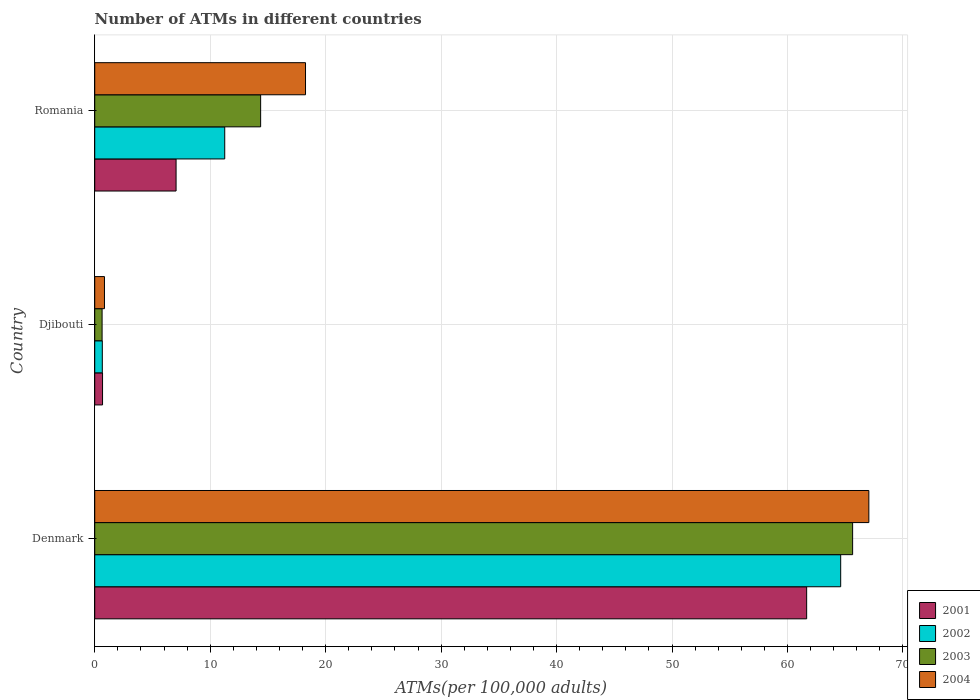How many groups of bars are there?
Your answer should be compact. 3. Are the number of bars per tick equal to the number of legend labels?
Your answer should be very brief. Yes. How many bars are there on the 3rd tick from the top?
Offer a very short reply. 4. How many bars are there on the 2nd tick from the bottom?
Your response must be concise. 4. What is the label of the 2nd group of bars from the top?
Offer a terse response. Djibouti. What is the number of ATMs in 2002 in Denmark?
Your answer should be compact. 64.61. Across all countries, what is the maximum number of ATMs in 2004?
Make the answer very short. 67.04. Across all countries, what is the minimum number of ATMs in 2003?
Keep it short and to the point. 0.64. In which country was the number of ATMs in 2004 maximum?
Offer a very short reply. Denmark. In which country was the number of ATMs in 2003 minimum?
Your answer should be very brief. Djibouti. What is the total number of ATMs in 2001 in the graph?
Give a very brief answer. 69.38. What is the difference between the number of ATMs in 2004 in Denmark and that in Djibouti?
Make the answer very short. 66.2. What is the difference between the number of ATMs in 2003 in Denmark and the number of ATMs in 2002 in Djibouti?
Your response must be concise. 64.98. What is the average number of ATMs in 2001 per country?
Your answer should be very brief. 23.13. What is the difference between the number of ATMs in 2001 and number of ATMs in 2003 in Denmark?
Offer a very short reply. -3.98. What is the ratio of the number of ATMs in 2002 in Denmark to that in Djibouti?
Offer a very short reply. 98.45. Is the difference between the number of ATMs in 2001 in Denmark and Romania greater than the difference between the number of ATMs in 2003 in Denmark and Romania?
Offer a very short reply. Yes. What is the difference between the highest and the second highest number of ATMs in 2003?
Offer a terse response. 51.27. What is the difference between the highest and the lowest number of ATMs in 2003?
Offer a terse response. 65. In how many countries, is the number of ATMs in 2004 greater than the average number of ATMs in 2004 taken over all countries?
Your response must be concise. 1. Is it the case that in every country, the sum of the number of ATMs in 2001 and number of ATMs in 2003 is greater than the sum of number of ATMs in 2004 and number of ATMs in 2002?
Ensure brevity in your answer.  No. What does the 1st bar from the top in Djibouti represents?
Provide a succinct answer. 2004. Is it the case that in every country, the sum of the number of ATMs in 2004 and number of ATMs in 2002 is greater than the number of ATMs in 2001?
Your response must be concise. Yes. Are all the bars in the graph horizontal?
Make the answer very short. Yes. How many countries are there in the graph?
Provide a succinct answer. 3. Are the values on the major ticks of X-axis written in scientific E-notation?
Your response must be concise. No. Does the graph contain any zero values?
Your answer should be very brief. No. Does the graph contain grids?
Make the answer very short. Yes. Where does the legend appear in the graph?
Offer a terse response. Bottom right. How many legend labels are there?
Your response must be concise. 4. How are the legend labels stacked?
Provide a short and direct response. Vertical. What is the title of the graph?
Offer a very short reply. Number of ATMs in different countries. What is the label or title of the X-axis?
Give a very brief answer. ATMs(per 100,0 adults). What is the label or title of the Y-axis?
Make the answer very short. Country. What is the ATMs(per 100,000 adults) in 2001 in Denmark?
Provide a succinct answer. 61.66. What is the ATMs(per 100,000 adults) in 2002 in Denmark?
Your answer should be very brief. 64.61. What is the ATMs(per 100,000 adults) in 2003 in Denmark?
Ensure brevity in your answer.  65.64. What is the ATMs(per 100,000 adults) of 2004 in Denmark?
Your response must be concise. 67.04. What is the ATMs(per 100,000 adults) in 2001 in Djibouti?
Your answer should be compact. 0.68. What is the ATMs(per 100,000 adults) of 2002 in Djibouti?
Your answer should be very brief. 0.66. What is the ATMs(per 100,000 adults) of 2003 in Djibouti?
Your answer should be very brief. 0.64. What is the ATMs(per 100,000 adults) in 2004 in Djibouti?
Provide a succinct answer. 0.84. What is the ATMs(per 100,000 adults) in 2001 in Romania?
Keep it short and to the point. 7.04. What is the ATMs(per 100,000 adults) in 2002 in Romania?
Your answer should be compact. 11.26. What is the ATMs(per 100,000 adults) in 2003 in Romania?
Offer a terse response. 14.37. What is the ATMs(per 100,000 adults) in 2004 in Romania?
Provide a succinct answer. 18.26. Across all countries, what is the maximum ATMs(per 100,000 adults) in 2001?
Ensure brevity in your answer.  61.66. Across all countries, what is the maximum ATMs(per 100,000 adults) of 2002?
Give a very brief answer. 64.61. Across all countries, what is the maximum ATMs(per 100,000 adults) in 2003?
Offer a terse response. 65.64. Across all countries, what is the maximum ATMs(per 100,000 adults) in 2004?
Give a very brief answer. 67.04. Across all countries, what is the minimum ATMs(per 100,000 adults) in 2001?
Offer a terse response. 0.68. Across all countries, what is the minimum ATMs(per 100,000 adults) of 2002?
Provide a short and direct response. 0.66. Across all countries, what is the minimum ATMs(per 100,000 adults) in 2003?
Your answer should be compact. 0.64. Across all countries, what is the minimum ATMs(per 100,000 adults) of 2004?
Offer a very short reply. 0.84. What is the total ATMs(per 100,000 adults) in 2001 in the graph?
Provide a short and direct response. 69.38. What is the total ATMs(per 100,000 adults) of 2002 in the graph?
Ensure brevity in your answer.  76.52. What is the total ATMs(per 100,000 adults) of 2003 in the graph?
Your answer should be compact. 80.65. What is the total ATMs(per 100,000 adults) of 2004 in the graph?
Keep it short and to the point. 86.14. What is the difference between the ATMs(per 100,000 adults) of 2001 in Denmark and that in Djibouti?
Provide a succinct answer. 60.98. What is the difference between the ATMs(per 100,000 adults) in 2002 in Denmark and that in Djibouti?
Offer a very short reply. 63.95. What is the difference between the ATMs(per 100,000 adults) in 2003 in Denmark and that in Djibouti?
Make the answer very short. 65. What is the difference between the ATMs(per 100,000 adults) in 2004 in Denmark and that in Djibouti?
Your answer should be very brief. 66.2. What is the difference between the ATMs(per 100,000 adults) in 2001 in Denmark and that in Romania?
Make the answer very short. 54.61. What is the difference between the ATMs(per 100,000 adults) in 2002 in Denmark and that in Romania?
Give a very brief answer. 53.35. What is the difference between the ATMs(per 100,000 adults) of 2003 in Denmark and that in Romania?
Ensure brevity in your answer.  51.27. What is the difference between the ATMs(per 100,000 adults) in 2004 in Denmark and that in Romania?
Provide a succinct answer. 48.79. What is the difference between the ATMs(per 100,000 adults) in 2001 in Djibouti and that in Romania?
Ensure brevity in your answer.  -6.37. What is the difference between the ATMs(per 100,000 adults) in 2002 in Djibouti and that in Romania?
Provide a short and direct response. -10.6. What is the difference between the ATMs(per 100,000 adults) of 2003 in Djibouti and that in Romania?
Provide a succinct answer. -13.73. What is the difference between the ATMs(per 100,000 adults) in 2004 in Djibouti and that in Romania?
Your response must be concise. -17.41. What is the difference between the ATMs(per 100,000 adults) in 2001 in Denmark and the ATMs(per 100,000 adults) in 2002 in Djibouti?
Your response must be concise. 61. What is the difference between the ATMs(per 100,000 adults) in 2001 in Denmark and the ATMs(per 100,000 adults) in 2003 in Djibouti?
Ensure brevity in your answer.  61.02. What is the difference between the ATMs(per 100,000 adults) in 2001 in Denmark and the ATMs(per 100,000 adults) in 2004 in Djibouti?
Keep it short and to the point. 60.81. What is the difference between the ATMs(per 100,000 adults) of 2002 in Denmark and the ATMs(per 100,000 adults) of 2003 in Djibouti?
Provide a succinct answer. 63.97. What is the difference between the ATMs(per 100,000 adults) in 2002 in Denmark and the ATMs(per 100,000 adults) in 2004 in Djibouti?
Ensure brevity in your answer.  63.76. What is the difference between the ATMs(per 100,000 adults) in 2003 in Denmark and the ATMs(per 100,000 adults) in 2004 in Djibouti?
Your answer should be very brief. 64.79. What is the difference between the ATMs(per 100,000 adults) of 2001 in Denmark and the ATMs(per 100,000 adults) of 2002 in Romania?
Offer a terse response. 50.4. What is the difference between the ATMs(per 100,000 adults) of 2001 in Denmark and the ATMs(per 100,000 adults) of 2003 in Romania?
Offer a very short reply. 47.29. What is the difference between the ATMs(per 100,000 adults) of 2001 in Denmark and the ATMs(per 100,000 adults) of 2004 in Romania?
Offer a terse response. 43.4. What is the difference between the ATMs(per 100,000 adults) of 2002 in Denmark and the ATMs(per 100,000 adults) of 2003 in Romania?
Ensure brevity in your answer.  50.24. What is the difference between the ATMs(per 100,000 adults) of 2002 in Denmark and the ATMs(per 100,000 adults) of 2004 in Romania?
Offer a terse response. 46.35. What is the difference between the ATMs(per 100,000 adults) in 2003 in Denmark and the ATMs(per 100,000 adults) in 2004 in Romania?
Your answer should be very brief. 47.38. What is the difference between the ATMs(per 100,000 adults) of 2001 in Djibouti and the ATMs(per 100,000 adults) of 2002 in Romania?
Your answer should be very brief. -10.58. What is the difference between the ATMs(per 100,000 adults) in 2001 in Djibouti and the ATMs(per 100,000 adults) in 2003 in Romania?
Your answer should be compact. -13.69. What is the difference between the ATMs(per 100,000 adults) of 2001 in Djibouti and the ATMs(per 100,000 adults) of 2004 in Romania?
Offer a terse response. -17.58. What is the difference between the ATMs(per 100,000 adults) of 2002 in Djibouti and the ATMs(per 100,000 adults) of 2003 in Romania?
Your response must be concise. -13.71. What is the difference between the ATMs(per 100,000 adults) in 2002 in Djibouti and the ATMs(per 100,000 adults) in 2004 in Romania?
Offer a terse response. -17.6. What is the difference between the ATMs(per 100,000 adults) in 2003 in Djibouti and the ATMs(per 100,000 adults) in 2004 in Romania?
Offer a terse response. -17.62. What is the average ATMs(per 100,000 adults) of 2001 per country?
Keep it short and to the point. 23.13. What is the average ATMs(per 100,000 adults) in 2002 per country?
Keep it short and to the point. 25.51. What is the average ATMs(per 100,000 adults) of 2003 per country?
Ensure brevity in your answer.  26.88. What is the average ATMs(per 100,000 adults) of 2004 per country?
Ensure brevity in your answer.  28.71. What is the difference between the ATMs(per 100,000 adults) of 2001 and ATMs(per 100,000 adults) of 2002 in Denmark?
Provide a succinct answer. -2.95. What is the difference between the ATMs(per 100,000 adults) of 2001 and ATMs(per 100,000 adults) of 2003 in Denmark?
Make the answer very short. -3.98. What is the difference between the ATMs(per 100,000 adults) of 2001 and ATMs(per 100,000 adults) of 2004 in Denmark?
Give a very brief answer. -5.39. What is the difference between the ATMs(per 100,000 adults) of 2002 and ATMs(per 100,000 adults) of 2003 in Denmark?
Your answer should be very brief. -1.03. What is the difference between the ATMs(per 100,000 adults) in 2002 and ATMs(per 100,000 adults) in 2004 in Denmark?
Keep it short and to the point. -2.44. What is the difference between the ATMs(per 100,000 adults) in 2003 and ATMs(per 100,000 adults) in 2004 in Denmark?
Offer a terse response. -1.41. What is the difference between the ATMs(per 100,000 adults) in 2001 and ATMs(per 100,000 adults) in 2002 in Djibouti?
Keep it short and to the point. 0.02. What is the difference between the ATMs(per 100,000 adults) of 2001 and ATMs(per 100,000 adults) of 2003 in Djibouti?
Ensure brevity in your answer.  0.04. What is the difference between the ATMs(per 100,000 adults) in 2001 and ATMs(per 100,000 adults) in 2004 in Djibouti?
Provide a short and direct response. -0.17. What is the difference between the ATMs(per 100,000 adults) of 2002 and ATMs(per 100,000 adults) of 2003 in Djibouti?
Offer a very short reply. 0.02. What is the difference between the ATMs(per 100,000 adults) in 2002 and ATMs(per 100,000 adults) in 2004 in Djibouti?
Make the answer very short. -0.19. What is the difference between the ATMs(per 100,000 adults) in 2003 and ATMs(per 100,000 adults) in 2004 in Djibouti?
Provide a succinct answer. -0.21. What is the difference between the ATMs(per 100,000 adults) in 2001 and ATMs(per 100,000 adults) in 2002 in Romania?
Provide a succinct answer. -4.21. What is the difference between the ATMs(per 100,000 adults) of 2001 and ATMs(per 100,000 adults) of 2003 in Romania?
Make the answer very short. -7.32. What is the difference between the ATMs(per 100,000 adults) in 2001 and ATMs(per 100,000 adults) in 2004 in Romania?
Your answer should be very brief. -11.21. What is the difference between the ATMs(per 100,000 adults) in 2002 and ATMs(per 100,000 adults) in 2003 in Romania?
Ensure brevity in your answer.  -3.11. What is the difference between the ATMs(per 100,000 adults) in 2002 and ATMs(per 100,000 adults) in 2004 in Romania?
Offer a terse response. -7. What is the difference between the ATMs(per 100,000 adults) of 2003 and ATMs(per 100,000 adults) of 2004 in Romania?
Your answer should be compact. -3.89. What is the ratio of the ATMs(per 100,000 adults) of 2001 in Denmark to that in Djibouti?
Your response must be concise. 91.18. What is the ratio of the ATMs(per 100,000 adults) of 2002 in Denmark to that in Djibouti?
Your answer should be very brief. 98.45. What is the ratio of the ATMs(per 100,000 adults) in 2003 in Denmark to that in Djibouti?
Provide a short and direct response. 102.88. What is the ratio of the ATMs(per 100,000 adults) of 2004 in Denmark to that in Djibouti?
Your answer should be very brief. 79.46. What is the ratio of the ATMs(per 100,000 adults) in 2001 in Denmark to that in Romania?
Your answer should be compact. 8.75. What is the ratio of the ATMs(per 100,000 adults) of 2002 in Denmark to that in Romania?
Keep it short and to the point. 5.74. What is the ratio of the ATMs(per 100,000 adults) of 2003 in Denmark to that in Romania?
Offer a very short reply. 4.57. What is the ratio of the ATMs(per 100,000 adults) in 2004 in Denmark to that in Romania?
Offer a very short reply. 3.67. What is the ratio of the ATMs(per 100,000 adults) in 2001 in Djibouti to that in Romania?
Make the answer very short. 0.1. What is the ratio of the ATMs(per 100,000 adults) in 2002 in Djibouti to that in Romania?
Provide a succinct answer. 0.06. What is the ratio of the ATMs(per 100,000 adults) of 2003 in Djibouti to that in Romania?
Your answer should be very brief. 0.04. What is the ratio of the ATMs(per 100,000 adults) in 2004 in Djibouti to that in Romania?
Provide a succinct answer. 0.05. What is the difference between the highest and the second highest ATMs(per 100,000 adults) of 2001?
Offer a very short reply. 54.61. What is the difference between the highest and the second highest ATMs(per 100,000 adults) of 2002?
Your answer should be compact. 53.35. What is the difference between the highest and the second highest ATMs(per 100,000 adults) in 2003?
Your answer should be compact. 51.27. What is the difference between the highest and the second highest ATMs(per 100,000 adults) of 2004?
Your answer should be very brief. 48.79. What is the difference between the highest and the lowest ATMs(per 100,000 adults) in 2001?
Your answer should be compact. 60.98. What is the difference between the highest and the lowest ATMs(per 100,000 adults) of 2002?
Provide a short and direct response. 63.95. What is the difference between the highest and the lowest ATMs(per 100,000 adults) in 2003?
Your response must be concise. 65. What is the difference between the highest and the lowest ATMs(per 100,000 adults) of 2004?
Your answer should be compact. 66.2. 